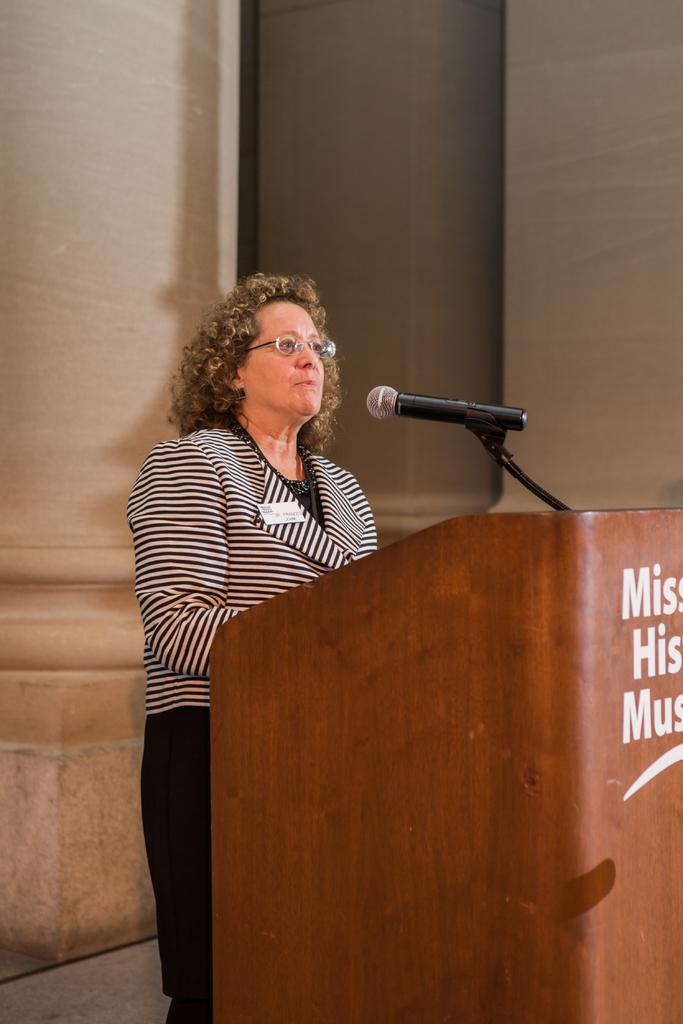What is the gender of the person in the image? The person in the image is a woman. What is the woman standing in front of? There is a podium with a microphone in front of the woman. What can be seen in the background of the image? There are pillars in the background of the image. What is written on the podium? Something is written on the podium. What type of gun is the woman holding in the image? There is no gun present in the image; the woman is standing in front of a podium with a microphone. 